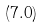Convert formula to latex. <formula><loc_0><loc_0><loc_500><loc_500>\left ( 7 . 0 \right )</formula> 